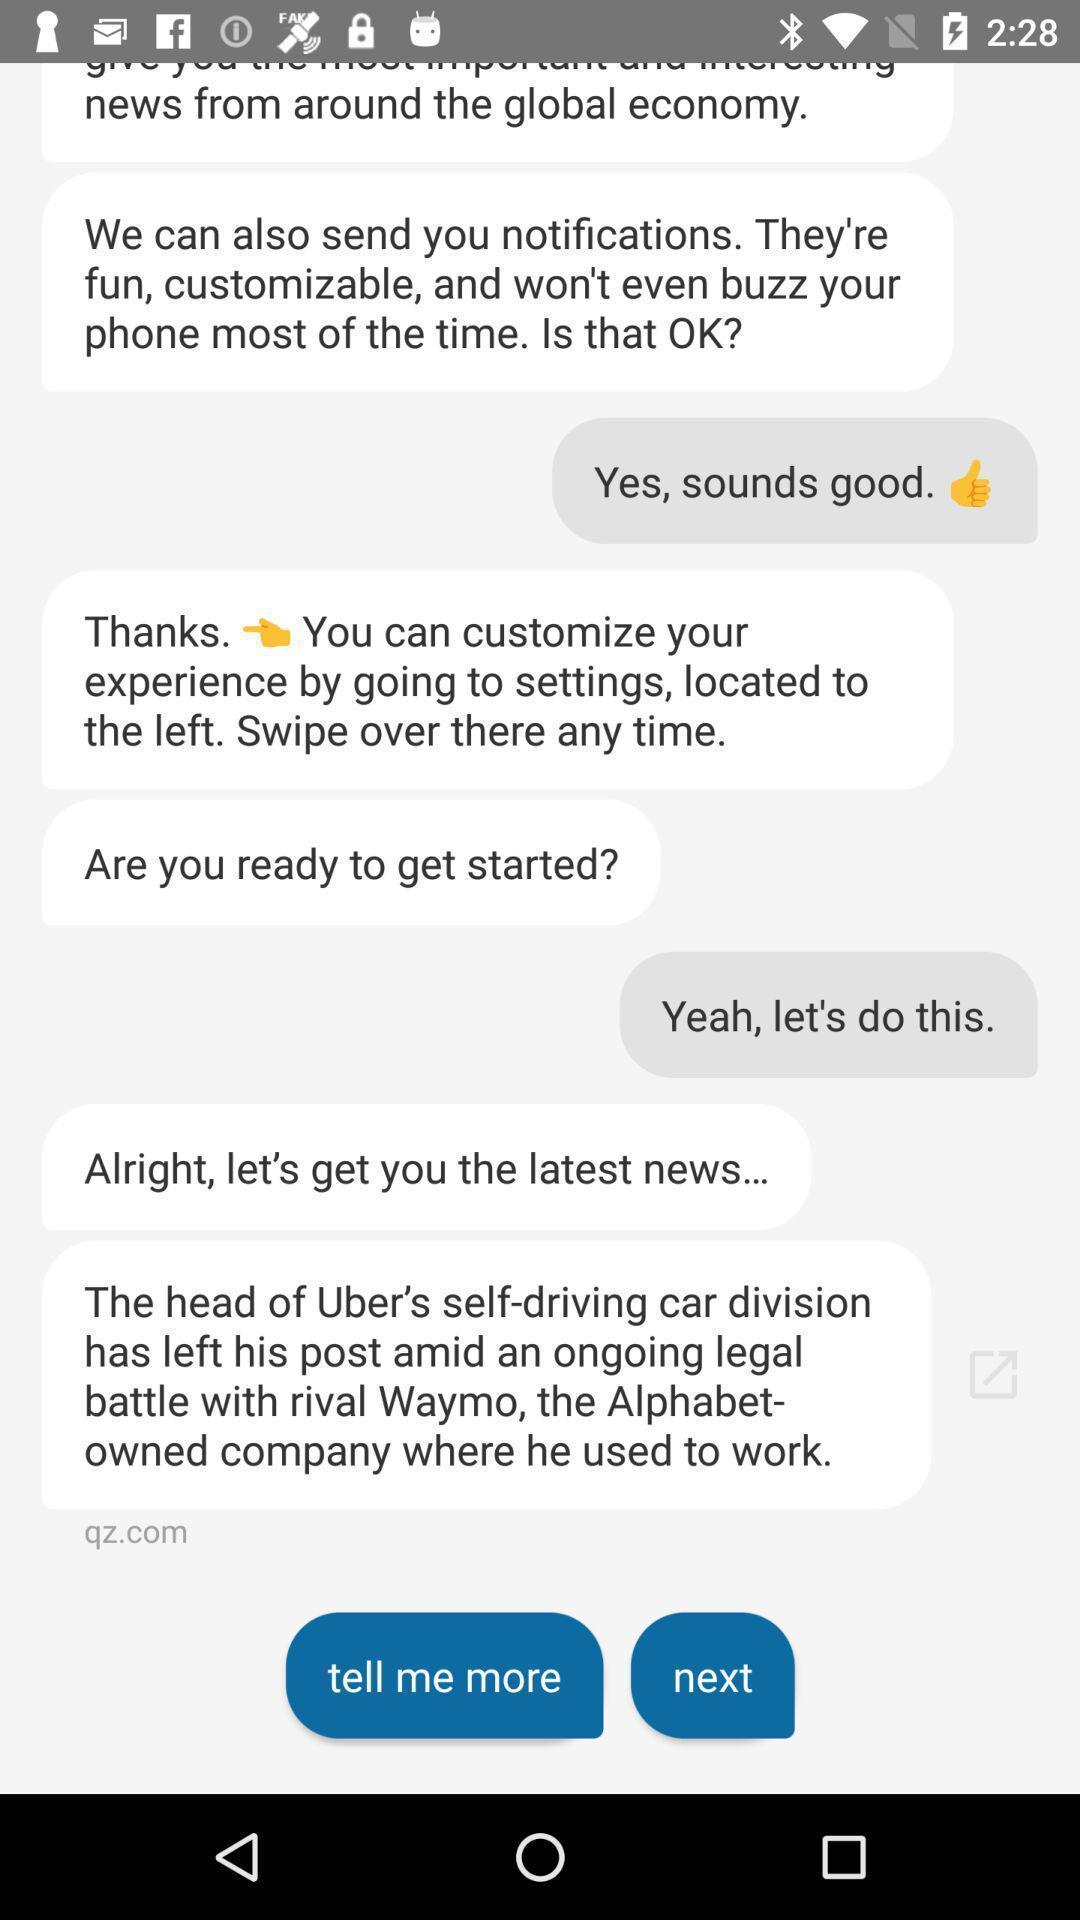Describe the visual elements of this screenshot. Screen shows text messages. 